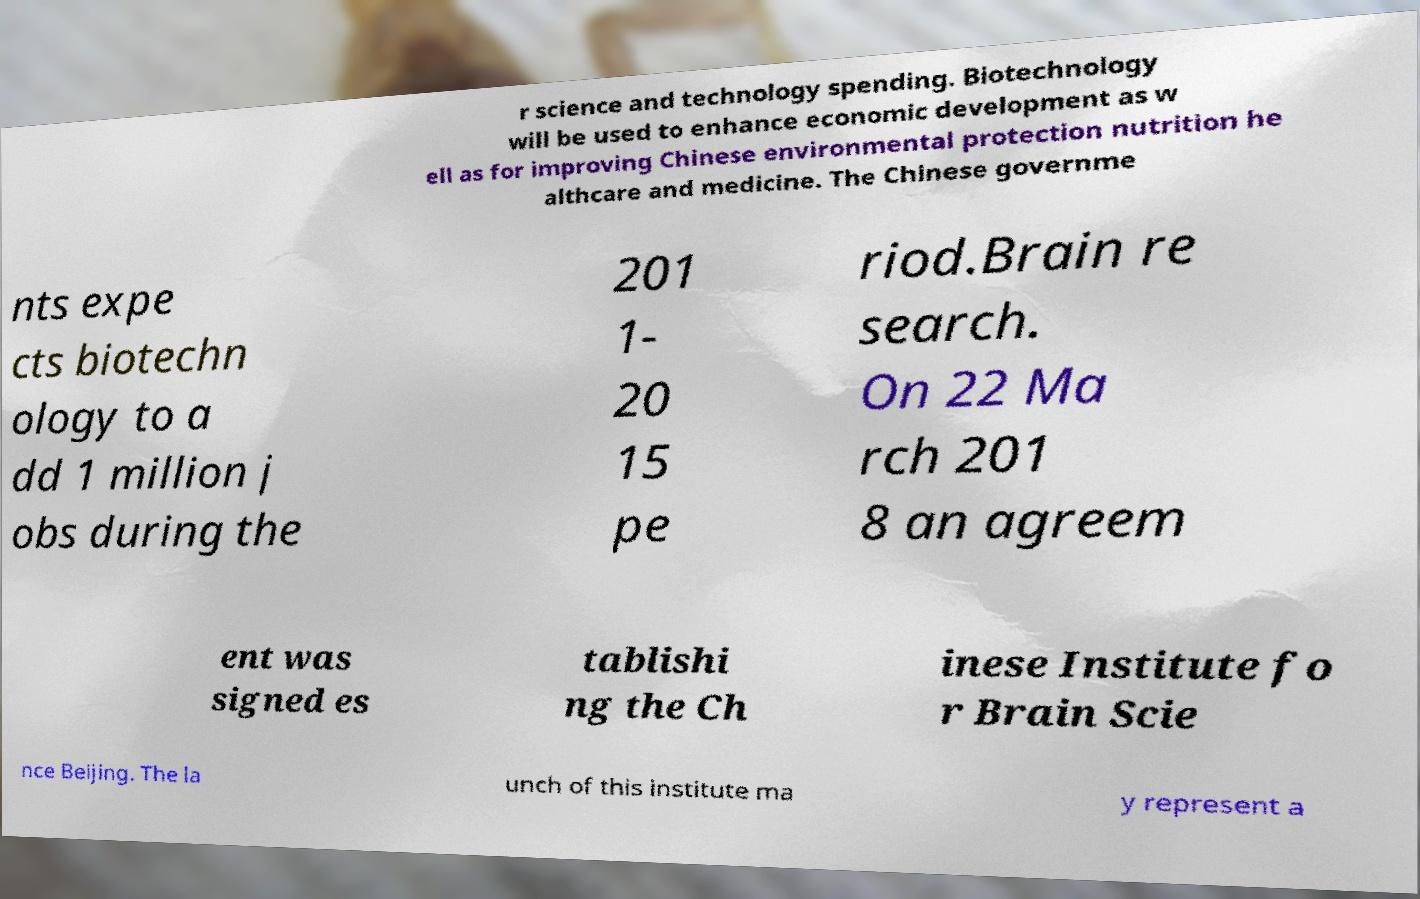Please identify and transcribe the text found in this image. r science and technology spending. Biotechnology will be used to enhance economic development as w ell as for improving Chinese environmental protection nutrition he althcare and medicine. The Chinese governme nts expe cts biotechn ology to a dd 1 million j obs during the 201 1- 20 15 pe riod.Brain re search. On 22 Ma rch 201 8 an agreem ent was signed es tablishi ng the Ch inese Institute fo r Brain Scie nce Beijing. The la unch of this institute ma y represent a 